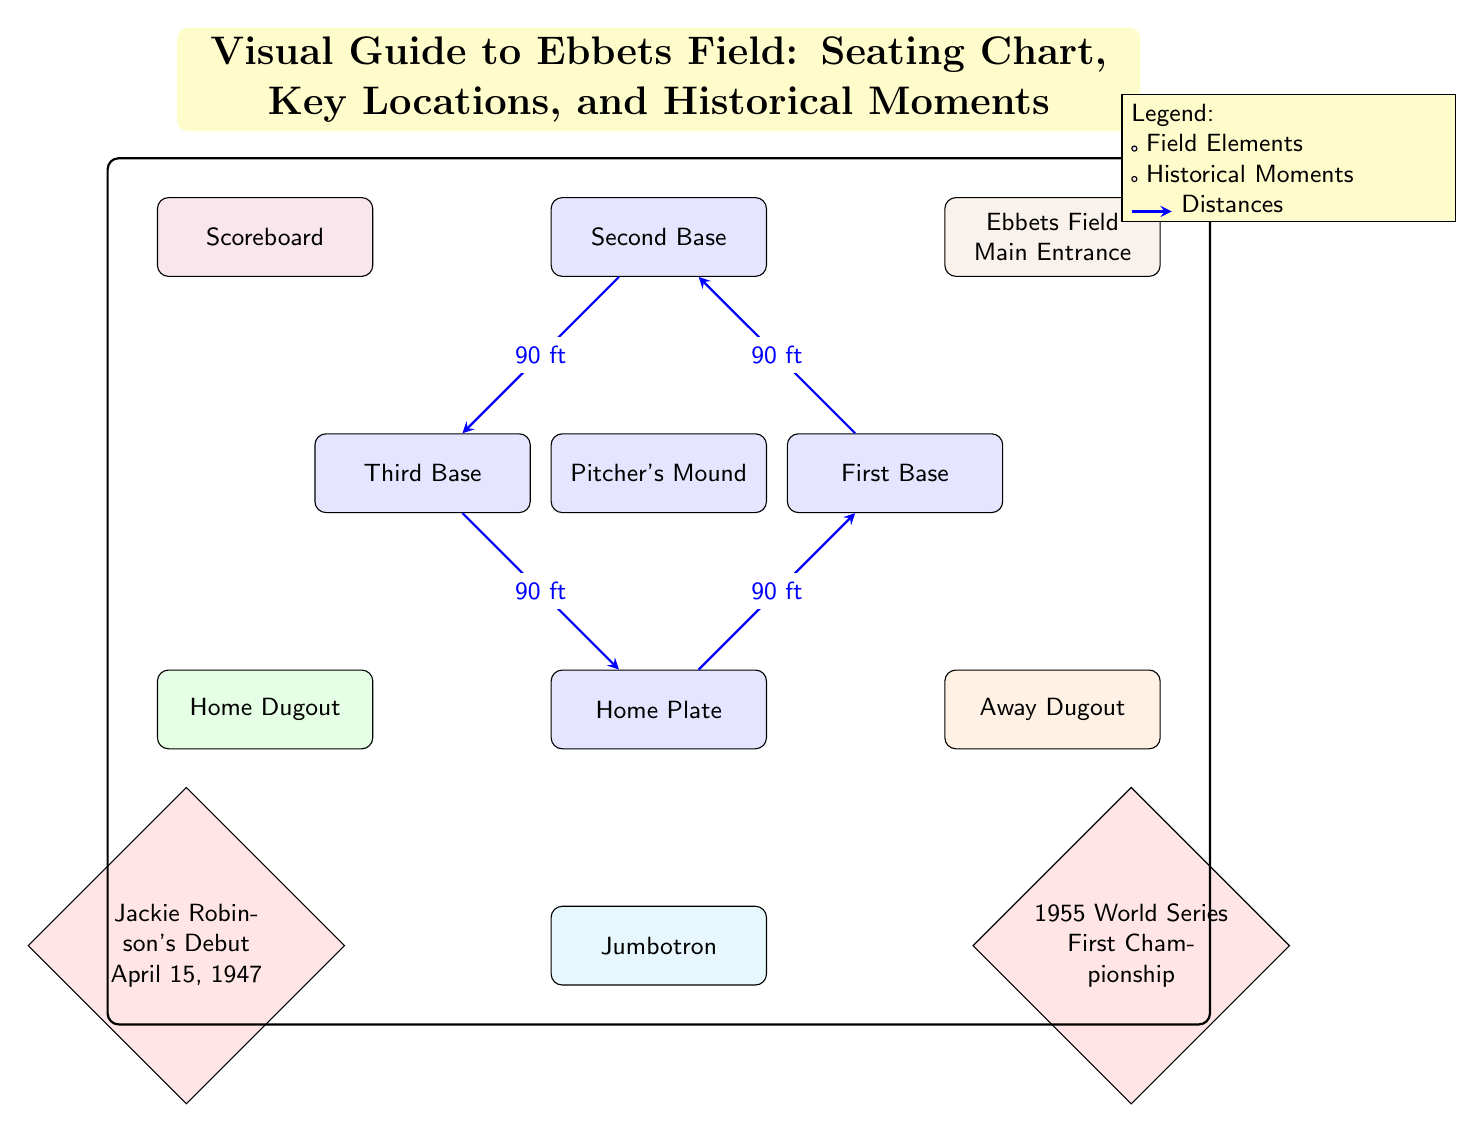What is located at home plate? The label in the diagram identifies "Home Plate" at the specific node labeled as such.
Answer: Home Plate How far is it from home plate to first base? The diagram indicates a distance label between "Home Plate" and "First Base" stating it is 90 ft apart.
Answer: 90 ft How many historical moments are noted in the diagram? The diagram features two historical moment nodes, labeled with significant events regarding Jackie Robinson and the 1955 World Series.
Answer: 2 What color represents the away dugout? The "Away Dugout" is filled with orange, distinguishing it from other elements in the diagram.
Answer: Orange Which location is directly below the pitcher's mound? The content of the diagram indicates that the "Jumbotron" is located directly below the "Pitcher's Mound." By observing the positions, the Jumbotron connects positionally as it appears underneath.
Answer: Jumbotron What significant event occurred on April 15, 1947, according to the diagram? The historical node specifically mentions "Jackie Robinson's Debut" on that date, making it clear and evident from the labeled context.
Answer: Jackie Robinson's Debut What are the coordinates for the scoreboard? The diagram places the "Scoreboard" at the coordinates (-5, 6). These coordinates are derived from the layout shown in the positioning of the node.
Answer: (-5, 6) Which component is closest to the Ebbets Field Main Entrance? The "Scoreboard" is located directly above the "Ebbets Field Main Entrance," making it the component positioned closest to it.
Answer: Scoreboard What would you call the diagram’s purpose in relation to Ebbets Field? Given the comprehensive layout of the seating chart, locations, and historical references, the main purpose is to serve as a visual guide.
Answer: Visual Guide 